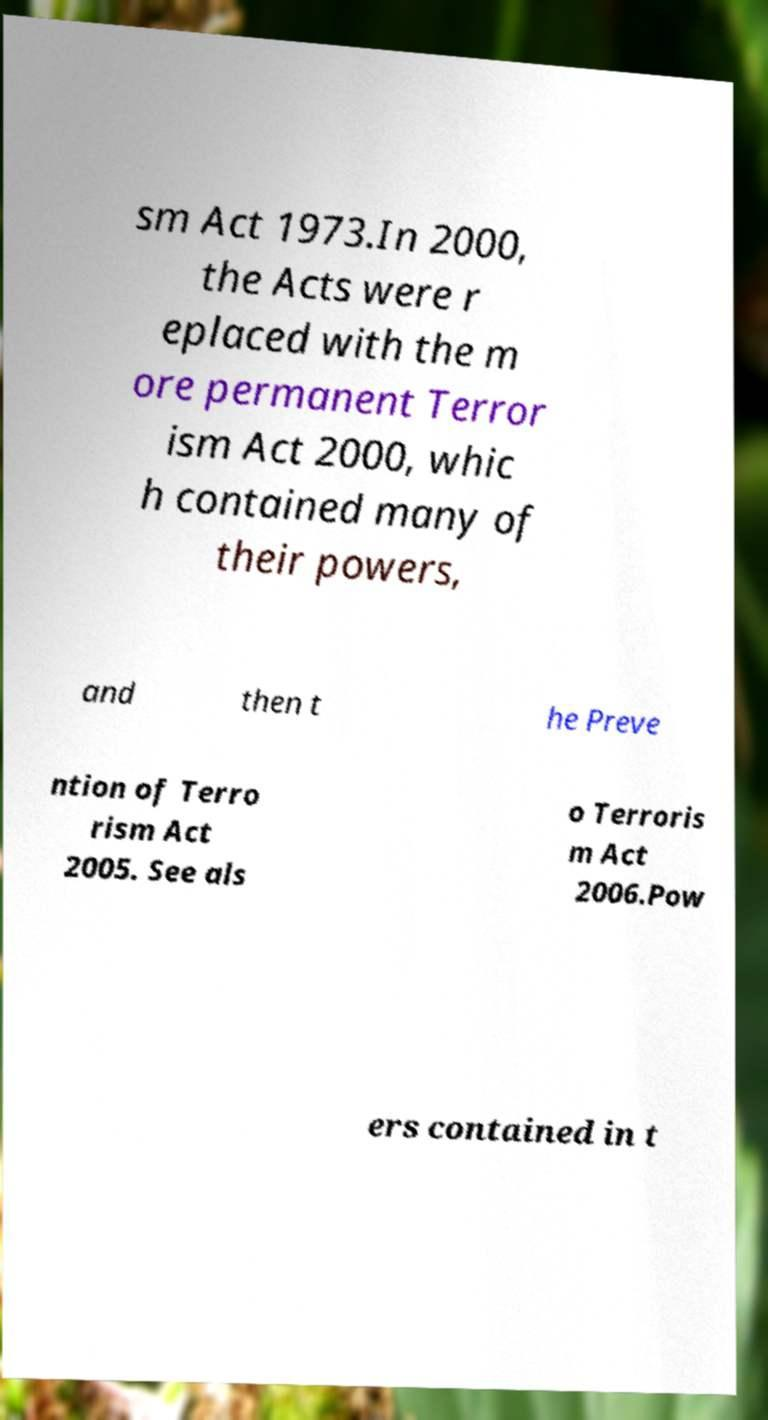There's text embedded in this image that I need extracted. Can you transcribe it verbatim? sm Act 1973.In 2000, the Acts were r eplaced with the m ore permanent Terror ism Act 2000, whic h contained many of their powers, and then t he Preve ntion of Terro rism Act 2005. See als o Terroris m Act 2006.Pow ers contained in t 